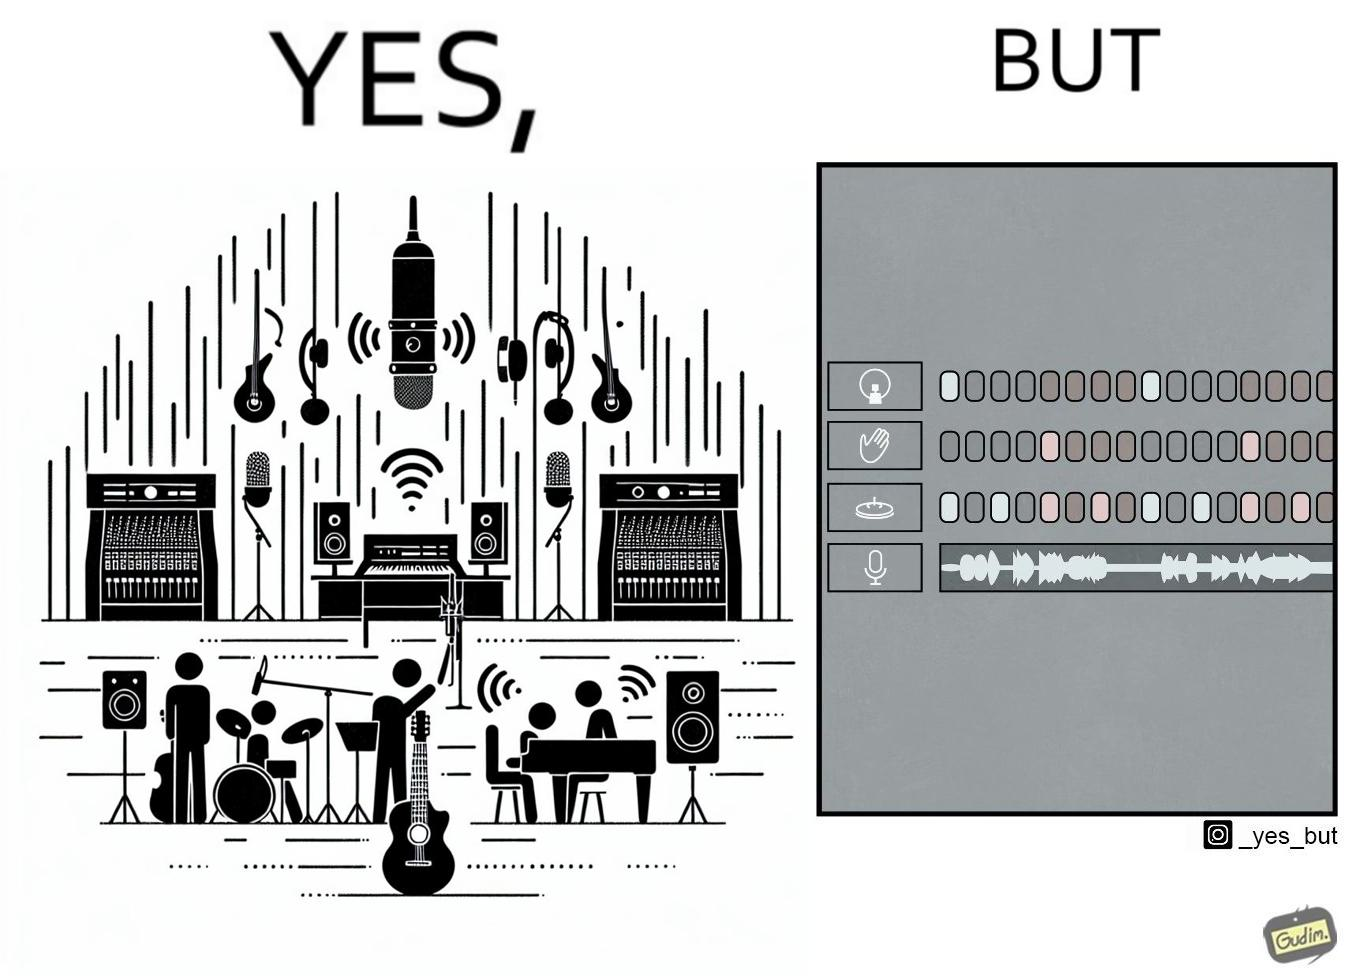Describe the contrast between the left and right parts of this image. In the left part of the image: The image shows a music studio with differnt kinds of instruments like guitar and saxophone, piano and recording  to make music. In the right part of the image: The image shows the view of an electornic equipment used to create music. It has buttons to record, play drums and other musical instruments. 